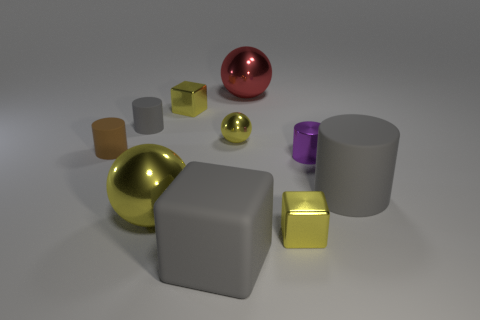Subtract all blue cylinders. Subtract all red balls. How many cylinders are left? 4 Subtract all balls. How many objects are left? 7 Add 8 red shiny spheres. How many red shiny spheres are left? 9 Add 5 purple matte cylinders. How many purple matte cylinders exist? 5 Subtract 0 green cylinders. How many objects are left? 10 Subtract all big gray shiny cylinders. Subtract all red things. How many objects are left? 9 